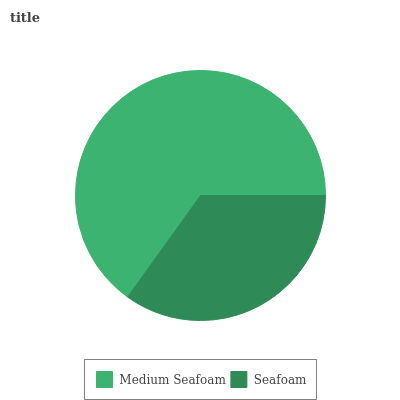Is Seafoam the minimum?
Answer yes or no. Yes. Is Medium Seafoam the maximum?
Answer yes or no. Yes. Is Seafoam the maximum?
Answer yes or no. No. Is Medium Seafoam greater than Seafoam?
Answer yes or no. Yes. Is Seafoam less than Medium Seafoam?
Answer yes or no. Yes. Is Seafoam greater than Medium Seafoam?
Answer yes or no. No. Is Medium Seafoam less than Seafoam?
Answer yes or no. No. Is Medium Seafoam the high median?
Answer yes or no. Yes. Is Seafoam the low median?
Answer yes or no. Yes. Is Seafoam the high median?
Answer yes or no. No. Is Medium Seafoam the low median?
Answer yes or no. No. 